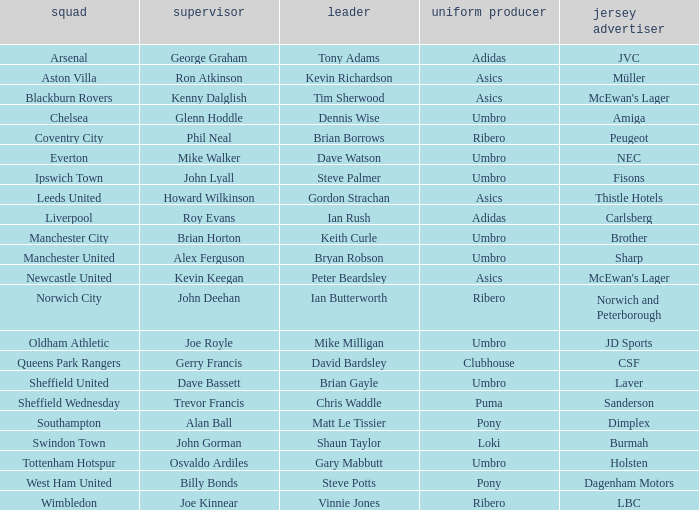Which manager has sheffield wednesday as the team? Trevor Francis. 